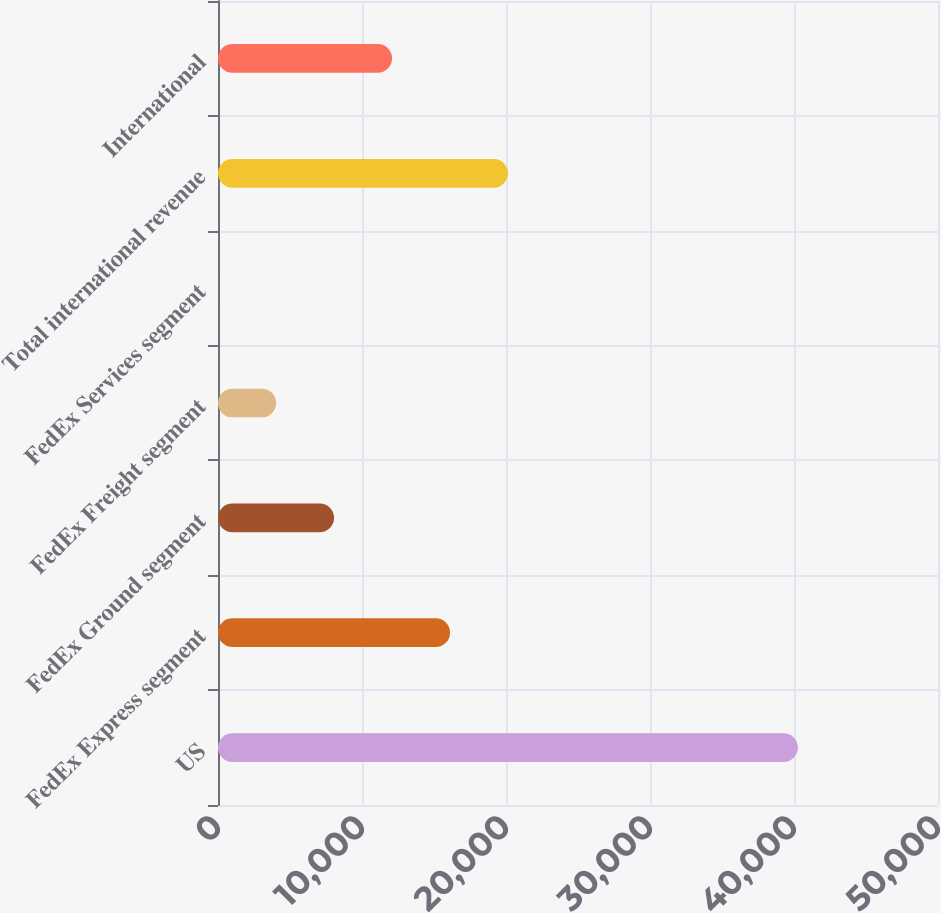Convert chart to OTSL. <chart><loc_0><loc_0><loc_500><loc_500><bar_chart><fcel>US<fcel>FedEx Express segment<fcel>FedEx Ground segment<fcel>FedEx Freight segment<fcel>FedEx Services segment<fcel>Total international revenue<fcel>International<nl><fcel>40269<fcel>16113.6<fcel>8061.8<fcel>4035.9<fcel>10<fcel>20139.5<fcel>12087.7<nl></chart> 